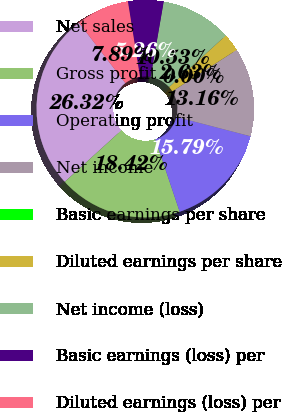Convert chart to OTSL. <chart><loc_0><loc_0><loc_500><loc_500><pie_chart><fcel>Net sales<fcel>Gross profit<fcel>Operating profit<fcel>Net income<fcel>Basic earnings per share<fcel>Diluted earnings per share<fcel>Net income (loss)<fcel>Basic earnings (loss) per<fcel>Diluted earnings (loss) per<nl><fcel>26.32%<fcel>18.42%<fcel>15.79%<fcel>13.16%<fcel>0.0%<fcel>2.63%<fcel>10.53%<fcel>5.26%<fcel>7.89%<nl></chart> 